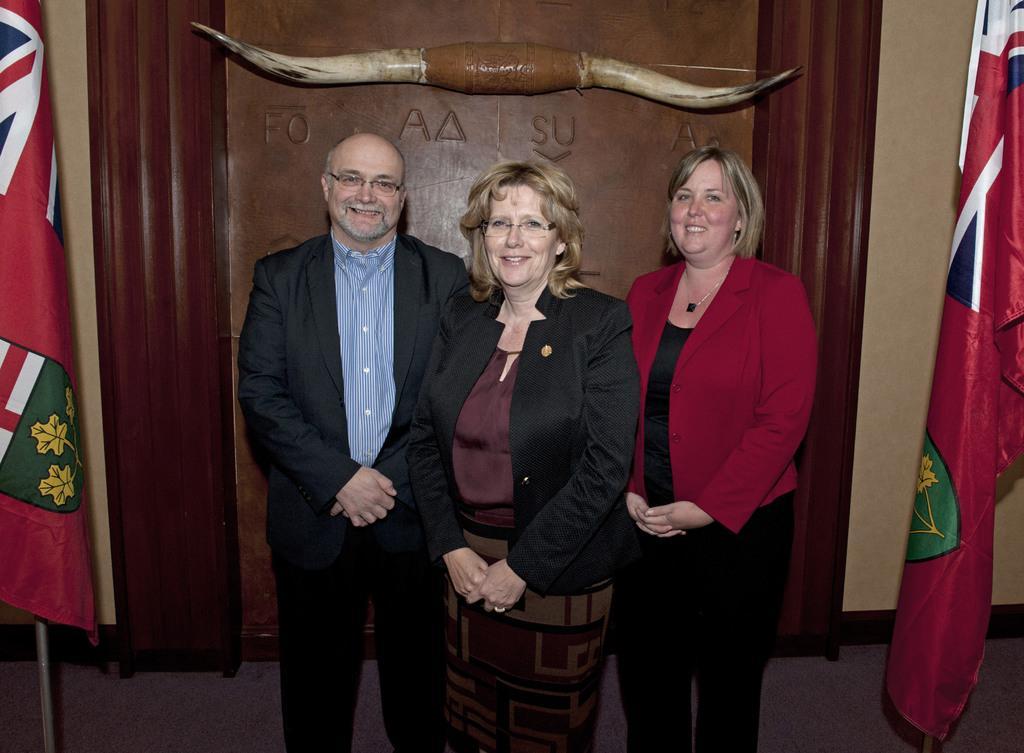Could you give a brief overview of what you see in this image? In the foreground of this image, there are two women and a man standing and posing to a camera. On either side of the image, there are flags. In the background, there are horns like object on the wall. 